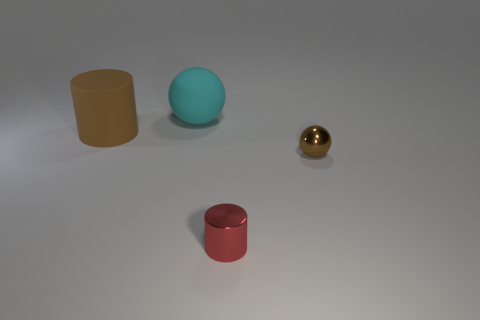Add 2 big cyan things. How many objects exist? 6 Subtract all blue cubes. How many gray cylinders are left? 0 Subtract all cyan things. Subtract all large rubber cylinders. How many objects are left? 2 Add 3 cyan objects. How many cyan objects are left? 4 Add 2 brown spheres. How many brown spheres exist? 3 Subtract all cyan spheres. How many spheres are left? 1 Subtract 0 yellow cylinders. How many objects are left? 4 Subtract 1 balls. How many balls are left? 1 Subtract all brown spheres. Subtract all red cubes. How many spheres are left? 1 